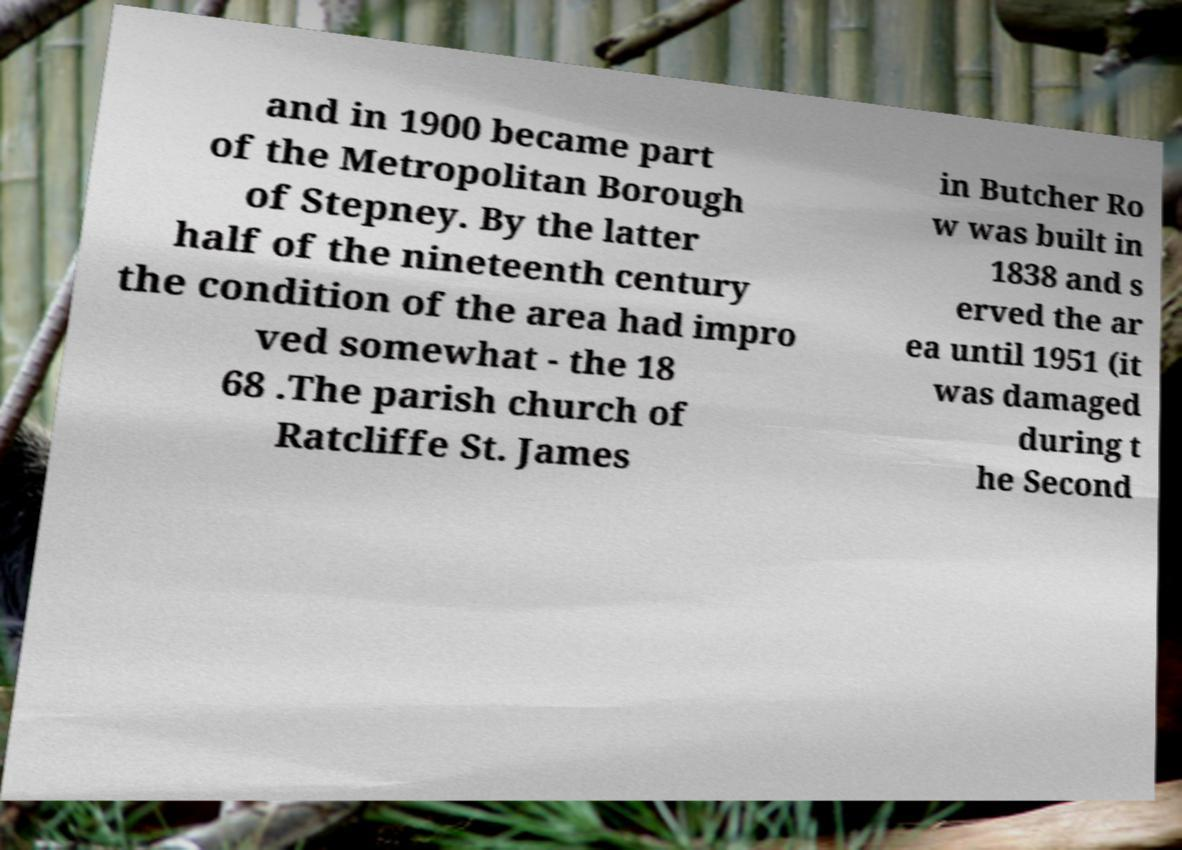For documentation purposes, I need the text within this image transcribed. Could you provide that? and in 1900 became part of the Metropolitan Borough of Stepney. By the latter half of the nineteenth century the condition of the area had impro ved somewhat - the 18 68 .The parish church of Ratcliffe St. James in Butcher Ro w was built in 1838 and s erved the ar ea until 1951 (it was damaged during t he Second 